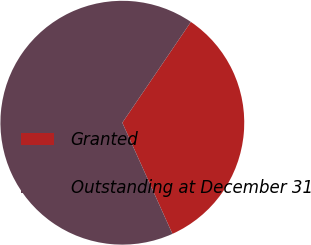Convert chart to OTSL. <chart><loc_0><loc_0><loc_500><loc_500><pie_chart><fcel>Granted<fcel>Outstanding at December 31<nl><fcel>33.76%<fcel>66.24%<nl></chart> 